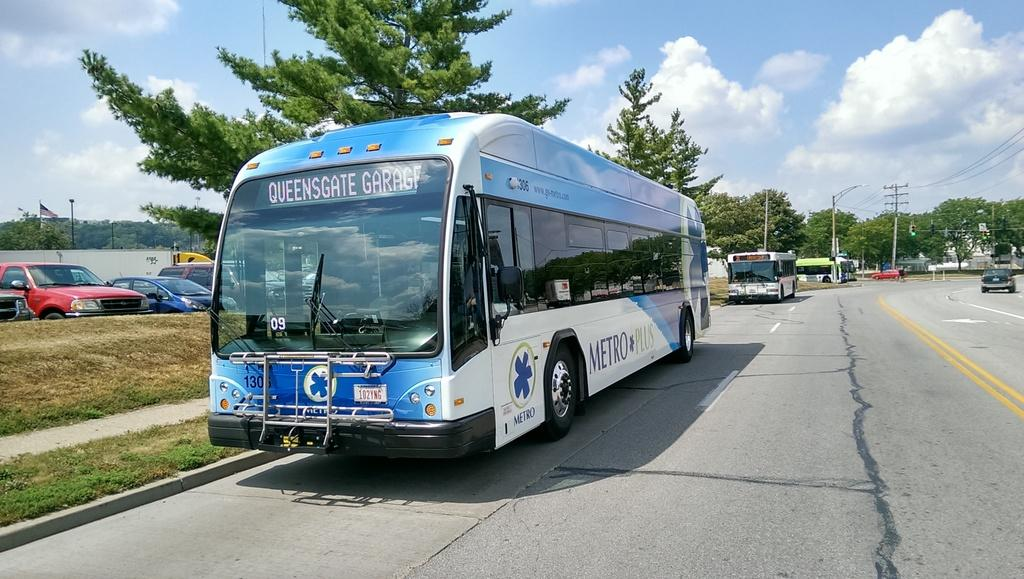<image>
Relay a brief, clear account of the picture shown. A bus with the text Metro Plus on the side is parked on a street next to a sidewalk. 